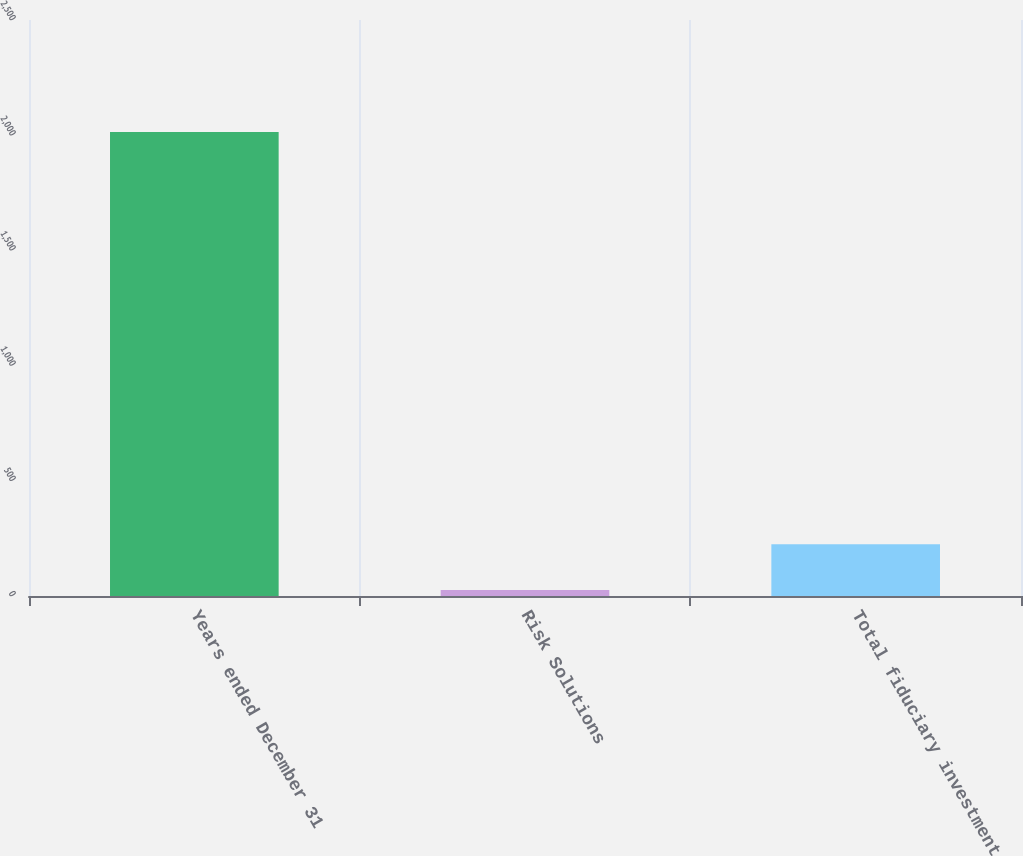<chart> <loc_0><loc_0><loc_500><loc_500><bar_chart><fcel>Years ended December 31<fcel>Risk Solutions<fcel>Total fiduciary investment<nl><fcel>2014<fcel>26<fcel>224.8<nl></chart> 